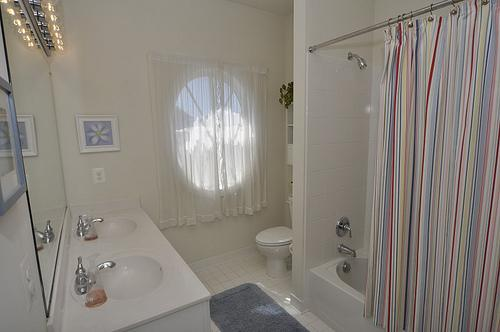Mention the item located right above the green plant. There is a white cabinet above the green plant on the toilet shelving. Enumerate a few items found on the wall behind the double vanity. A full-length lighted mirror, a white framed daisy flower, and a white flower painting are on the wall behind the double vanity. Does the slate blue bath rug have an intricate geometric pattern on it? The image only provides information regarding the position and size of the slate blue bath rug, and there is no mention of any intricate geometric pattern on it. Is the white toilet behind bathmat mounted on the wall? No, it's not mentioned in the image. Is the green plant over the toilet in a large blue ceramic pot? The image only describes size, position, and the presence of a green plant over the toilet, but there is no mention of the plant being in any kind of pot, let alone a large blue ceramic one. Is there a small statue on the double basins vanity sink? The image only provides information about position and size for the double basins vanity sink but does not mention any small statue placed on it. Is the exposed light bulb above the round bathroom window? The exposed light bulbs are described as being in position X:30 Y:0 - they are not mentioned to be placed above the round bathroom window. Is the framed painting of a daisy on the wall surrounded by a red frame? The painting in the image is described as "white framed daisy flower", which indicates that the frame is white, not red. 